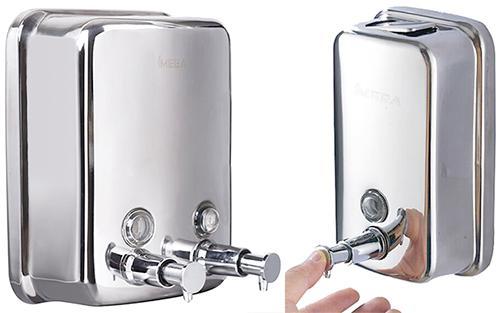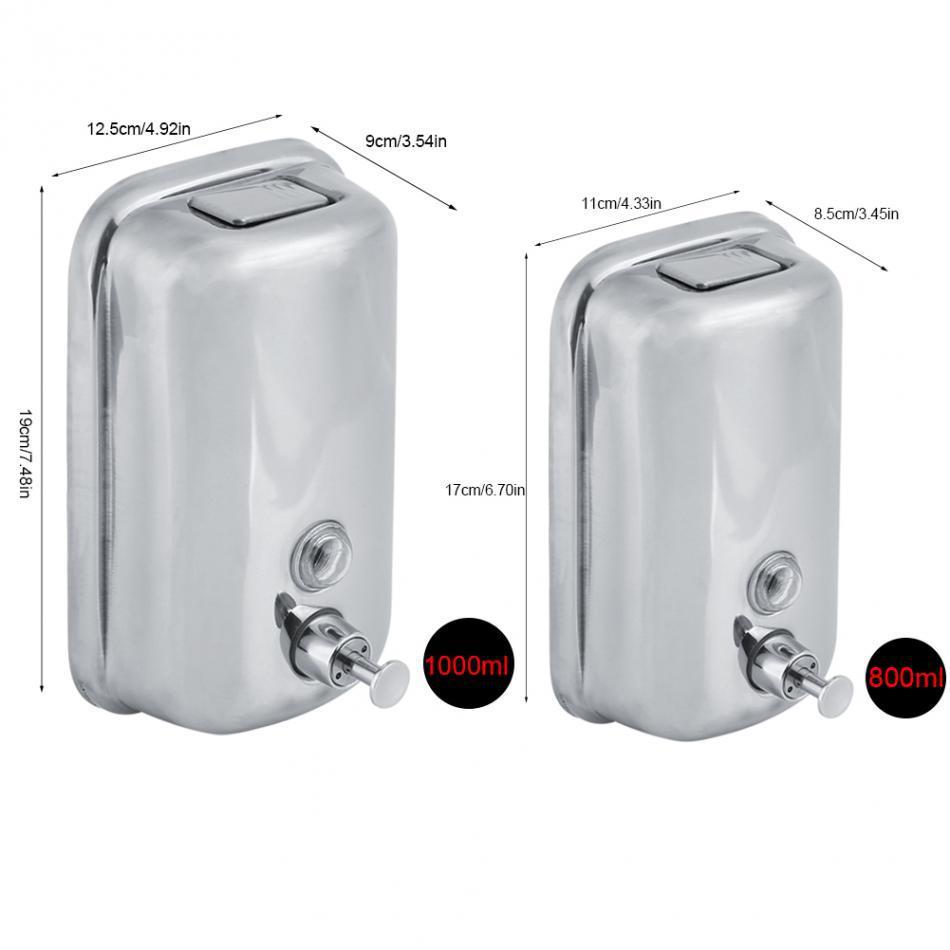The first image is the image on the left, the second image is the image on the right. Evaluate the accuracy of this statement regarding the images: "There are exactly two all metal dispensers.". Is it true? Answer yes or no. No. The first image is the image on the left, the second image is the image on the right. Given the left and right images, does the statement "there is a soap dispenser with a thumb pushing the dispenser plunger" hold true? Answer yes or no. Yes. 